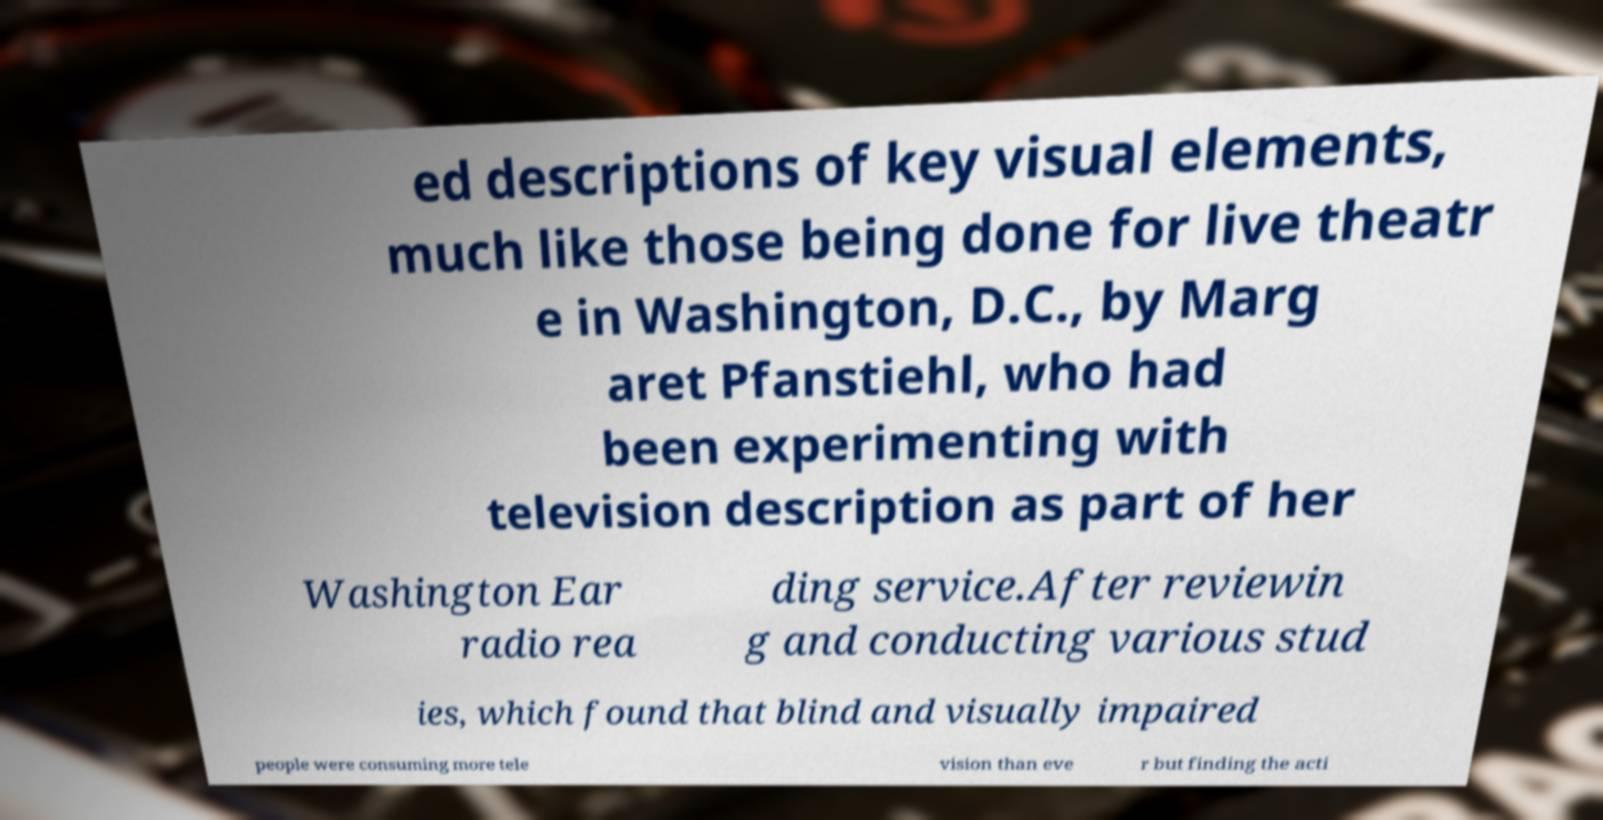Can you read and provide the text displayed in the image?This photo seems to have some interesting text. Can you extract and type it out for me? ed descriptions of key visual elements, much like those being done for live theatr e in Washington, D.C., by Marg aret Pfanstiehl, who had been experimenting with television description as part of her Washington Ear radio rea ding service.After reviewin g and conducting various stud ies, which found that blind and visually impaired people were consuming more tele vision than eve r but finding the acti 